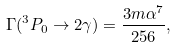<formula> <loc_0><loc_0><loc_500><loc_500>\Gamma ( ^ { 3 } P _ { 0 } \rightarrow 2 \gamma ) = \frac { 3 m \alpha ^ { 7 } } { 2 5 6 } ,</formula> 